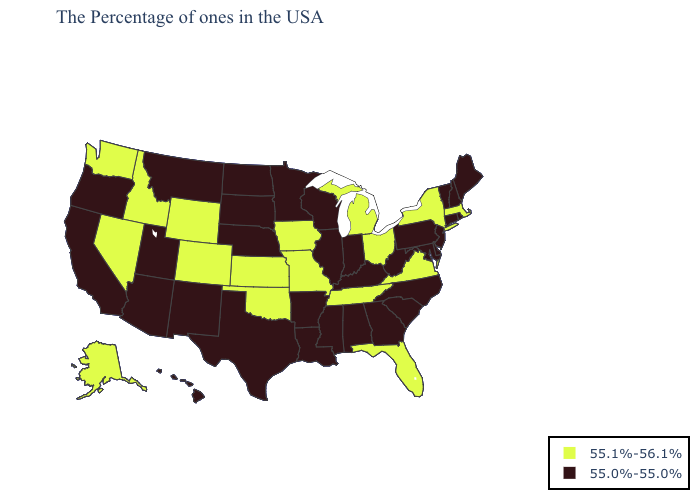What is the value of Nebraska?
Quick response, please. 55.0%-55.0%. Name the states that have a value in the range 55.0%-55.0%?
Be succinct. Maine, Rhode Island, New Hampshire, Vermont, Connecticut, New Jersey, Delaware, Maryland, Pennsylvania, North Carolina, South Carolina, West Virginia, Georgia, Kentucky, Indiana, Alabama, Wisconsin, Illinois, Mississippi, Louisiana, Arkansas, Minnesota, Nebraska, Texas, South Dakota, North Dakota, New Mexico, Utah, Montana, Arizona, California, Oregon, Hawaii. Does North Dakota have a higher value than Alaska?
Quick response, please. No. Among the states that border Alabama , which have the highest value?
Answer briefly. Florida, Tennessee. What is the highest value in states that border Nevada?
Answer briefly. 55.1%-56.1%. What is the highest value in states that border South Carolina?
Quick response, please. 55.0%-55.0%. Does Ohio have the same value as Indiana?
Keep it brief. No. Does Delaware have the lowest value in the USA?
Short answer required. Yes. Name the states that have a value in the range 55.1%-56.1%?
Give a very brief answer. Massachusetts, New York, Virginia, Ohio, Florida, Michigan, Tennessee, Missouri, Iowa, Kansas, Oklahoma, Wyoming, Colorado, Idaho, Nevada, Washington, Alaska. Name the states that have a value in the range 55.0%-55.0%?
Keep it brief. Maine, Rhode Island, New Hampshire, Vermont, Connecticut, New Jersey, Delaware, Maryland, Pennsylvania, North Carolina, South Carolina, West Virginia, Georgia, Kentucky, Indiana, Alabama, Wisconsin, Illinois, Mississippi, Louisiana, Arkansas, Minnesota, Nebraska, Texas, South Dakota, North Dakota, New Mexico, Utah, Montana, Arizona, California, Oregon, Hawaii. Does Tennessee have the lowest value in the USA?
Concise answer only. No. Does the map have missing data?
Give a very brief answer. No. Among the states that border Mississippi , which have the highest value?
Be succinct. Tennessee. Name the states that have a value in the range 55.0%-55.0%?
Keep it brief. Maine, Rhode Island, New Hampshire, Vermont, Connecticut, New Jersey, Delaware, Maryland, Pennsylvania, North Carolina, South Carolina, West Virginia, Georgia, Kentucky, Indiana, Alabama, Wisconsin, Illinois, Mississippi, Louisiana, Arkansas, Minnesota, Nebraska, Texas, South Dakota, North Dakota, New Mexico, Utah, Montana, Arizona, California, Oregon, Hawaii. Name the states that have a value in the range 55.0%-55.0%?
Short answer required. Maine, Rhode Island, New Hampshire, Vermont, Connecticut, New Jersey, Delaware, Maryland, Pennsylvania, North Carolina, South Carolina, West Virginia, Georgia, Kentucky, Indiana, Alabama, Wisconsin, Illinois, Mississippi, Louisiana, Arkansas, Minnesota, Nebraska, Texas, South Dakota, North Dakota, New Mexico, Utah, Montana, Arizona, California, Oregon, Hawaii. 